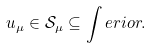<formula> <loc_0><loc_0><loc_500><loc_500>u _ { \mu } \in \mathcal { S } _ { \mu } \subseteq \int e r i o r .</formula> 